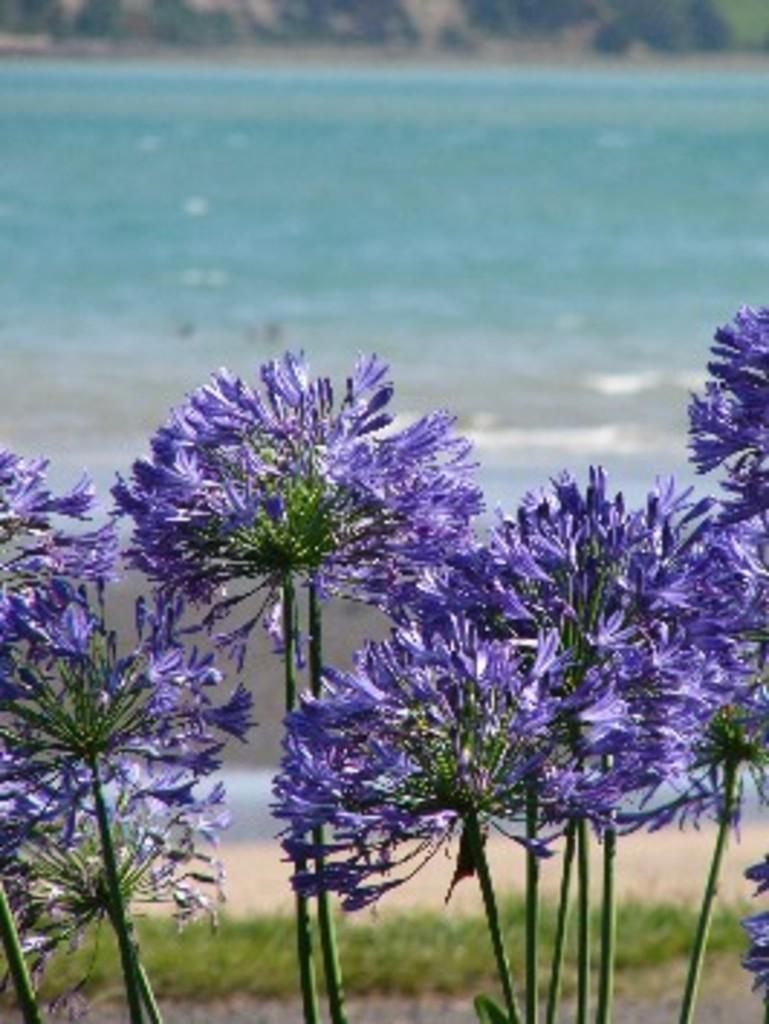What type of plants can be seen in the image? There are plants with flowers in the image. What can be seen beneath the plants? The ground is visible in the image. What type of vegetation is present in the image? There is grass in the image. What else can be seen in the image besides plants and grass? There is water visible in the image. Can you see any roots growing out of the plants in the image? There is no mention of roots in the provided facts, so we cannot determine if any roots are visible in the image. 